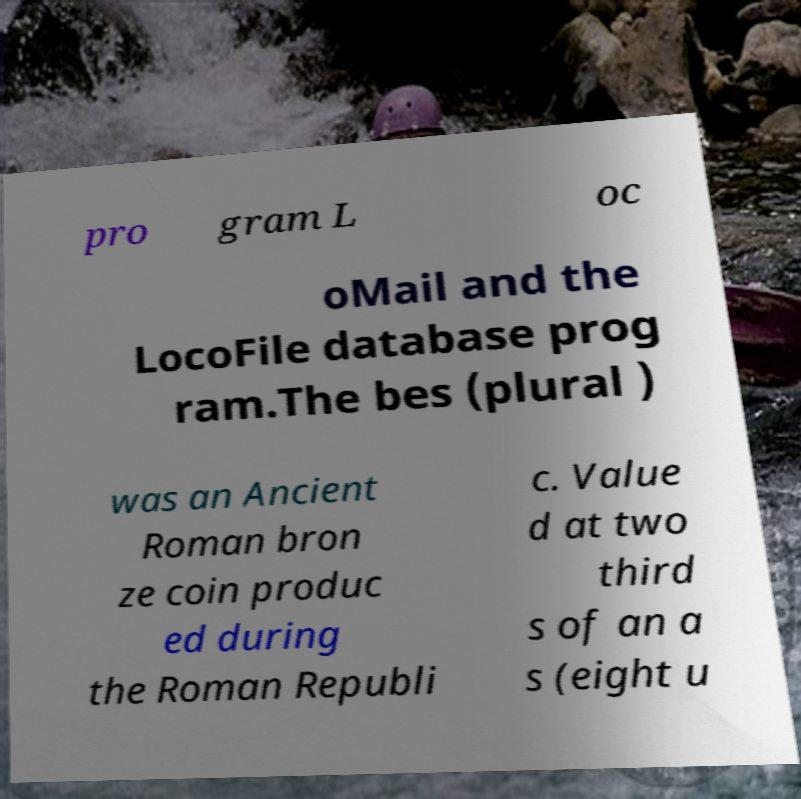Can you accurately transcribe the text from the provided image for me? pro gram L oc oMail and the LocoFile database prog ram.The bes (plural ) was an Ancient Roman bron ze coin produc ed during the Roman Republi c. Value d at two third s of an a s (eight u 